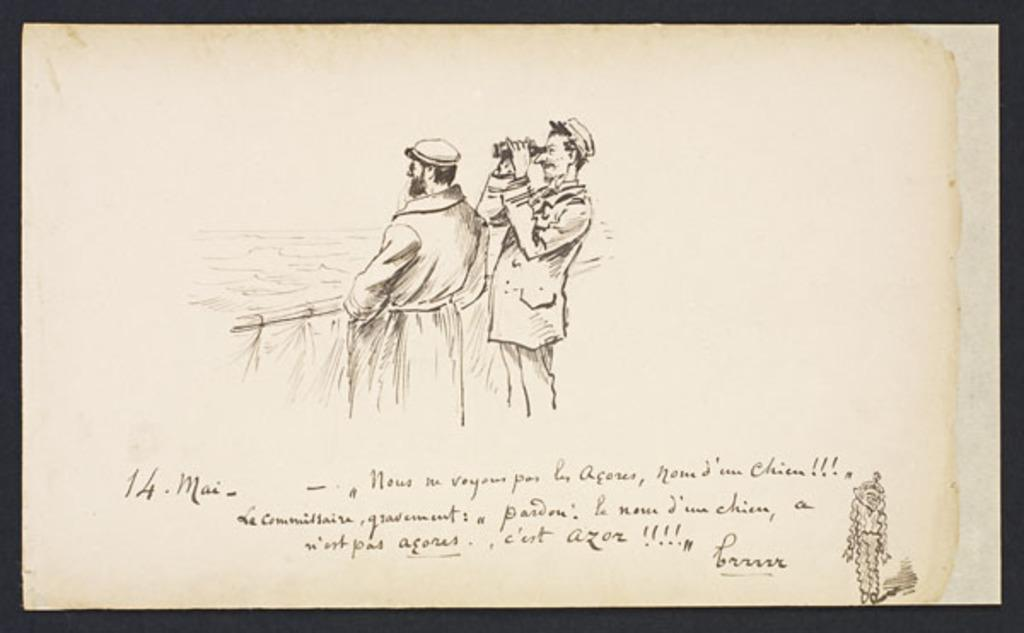What is depicted on the paper in the image? The paper contains a drawing of two people. What are the two people in the drawing wearing? The two people in the drawing are wearing clothes and hats. Is there any text on the paper? Yes, there is text on the paper. What is the nature of the paper in the image? The paper is an object. What type of grain is being harvested in the background of the image? There is no grain or harvesting activity depicted in the image; it features a drawing on a piece of paper. 